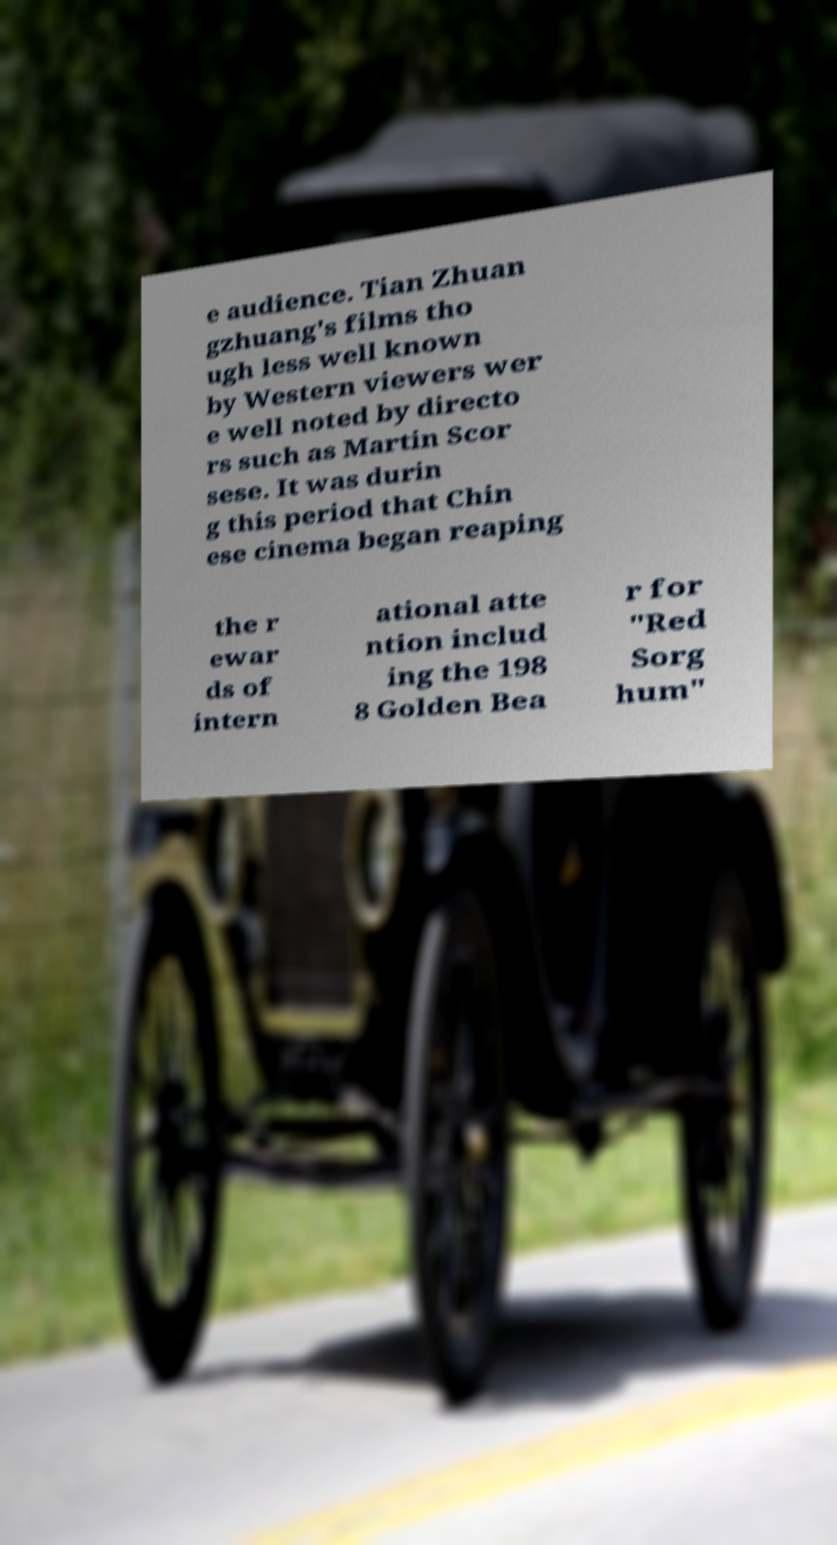There's text embedded in this image that I need extracted. Can you transcribe it verbatim? e audience. Tian Zhuan gzhuang's films tho ugh less well known by Western viewers wer e well noted by directo rs such as Martin Scor sese. It was durin g this period that Chin ese cinema began reaping the r ewar ds of intern ational atte ntion includ ing the 198 8 Golden Bea r for "Red Sorg hum" 